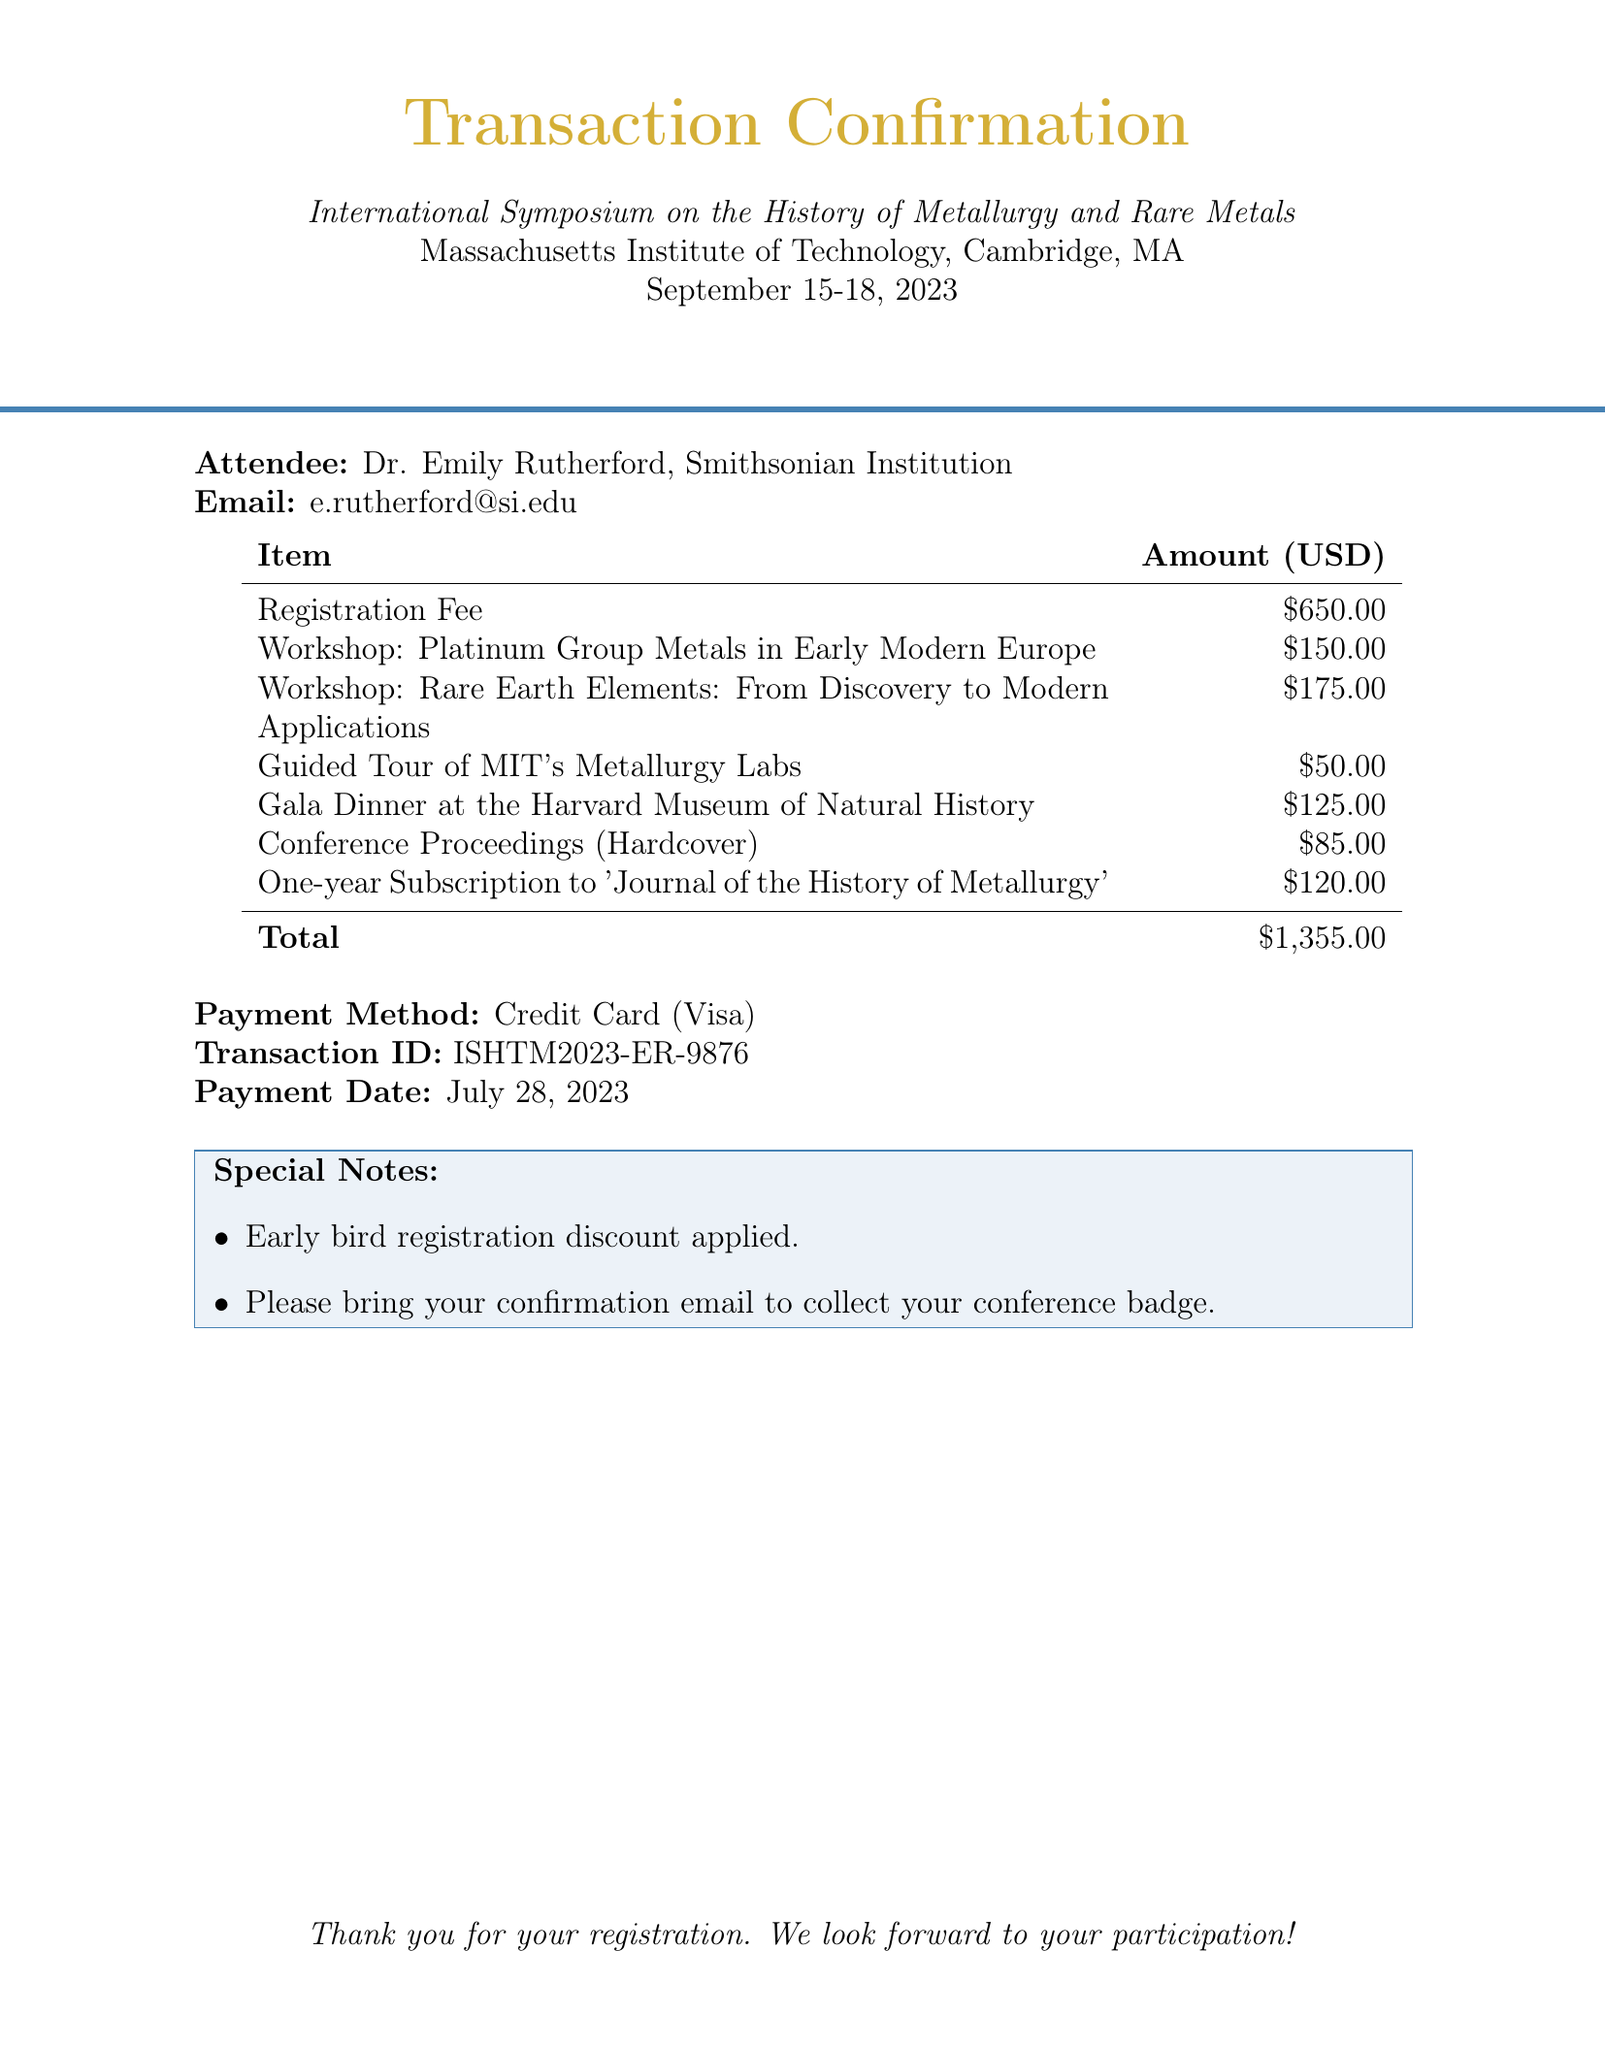What is the total amount paid? The total amount is listed at the bottom of the payment confirmation, which includes the registration fee, workshops, special events, and additional items.
Answer: $1,355.00 Who is the instructor of the workshop on Rare Earth Elements? The instructor's name for this specific workshop is provided in the workshops section of the document.
Answer: Dr. Yasuko Nakamura What is the date of the conference? The date is explicitly mentioned in the document header and reflects the event schedule.
Answer: September 15-18, 2023 What method was used for payment? The payment method is specified in the document, indicating how the registration fees were settled.
Answer: Credit Card (Visa) How many workshops were registered for? The number of workshops can be determined by counting the entries under the workshops section.
Answer: 2 What is the fee for attending the Gala Dinner? The fee for this special event is clearly stated in the itemized costs within the document.
Answer: $125.00 What special note is included regarding registration? The document includes specific instructions or notes that should be noted by the attendee.
Answer: Early bird registration discount applied What is the transaction ID? The transaction ID is a unique identifier provided in the payment confirmation section for tracking purposes.
Answer: ISHTM2023-ER-9876 